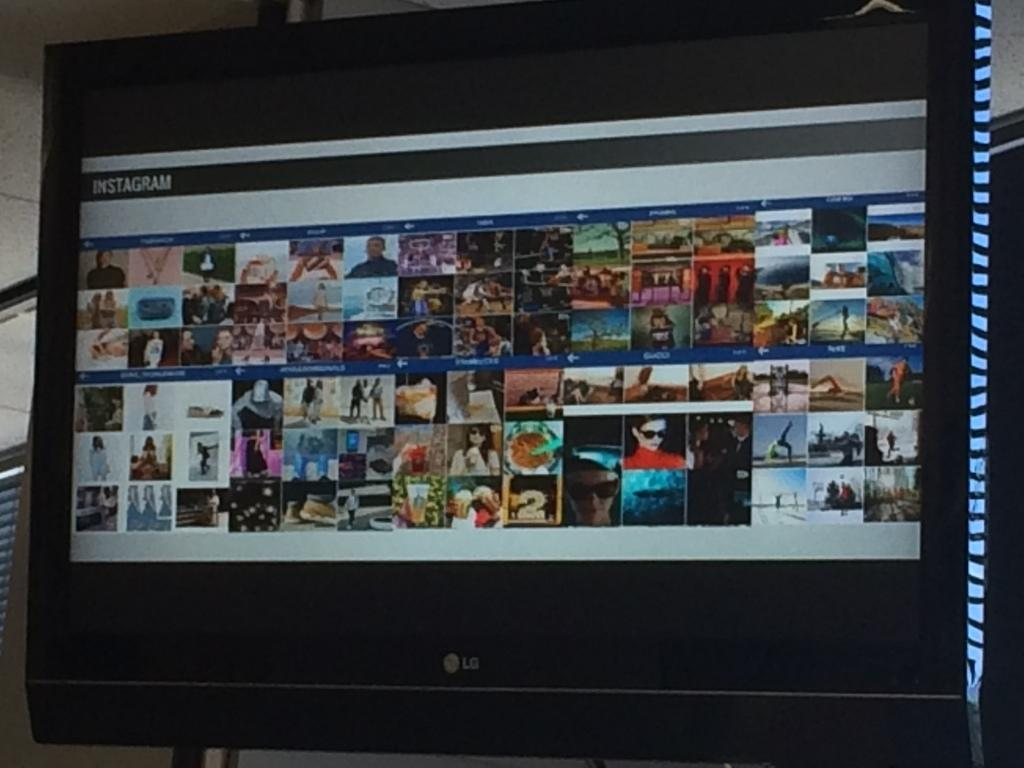Provide a one-sentence caption for the provided image. A LG computer monitor displaying a variety of thumbnails. 